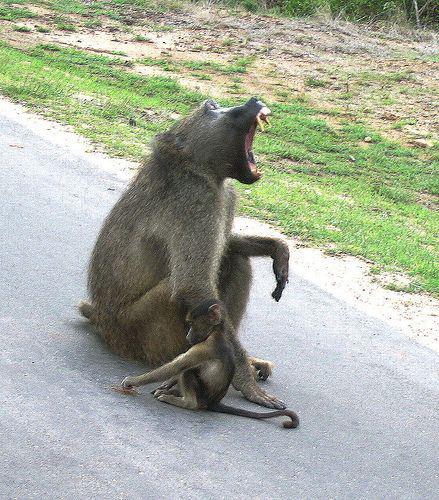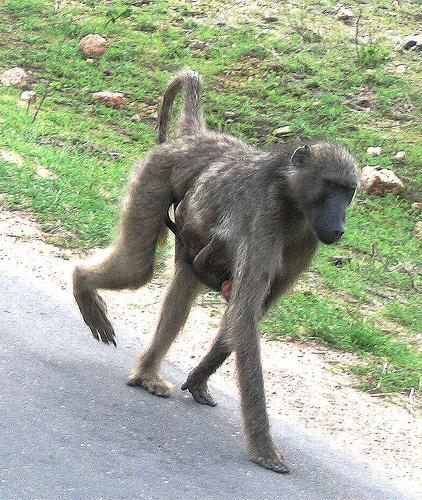The first image is the image on the left, the second image is the image on the right. Given the left and right images, does the statement "The right image contains at least two monkeys." hold true? Answer yes or no. No. The first image is the image on the left, the second image is the image on the right. Analyze the images presented: Is the assertion "A baby baboon is clinging to an adult baboon walking on all fours in one image, and each image contains at least one baby baboon." valid? Answer yes or no. Yes. 